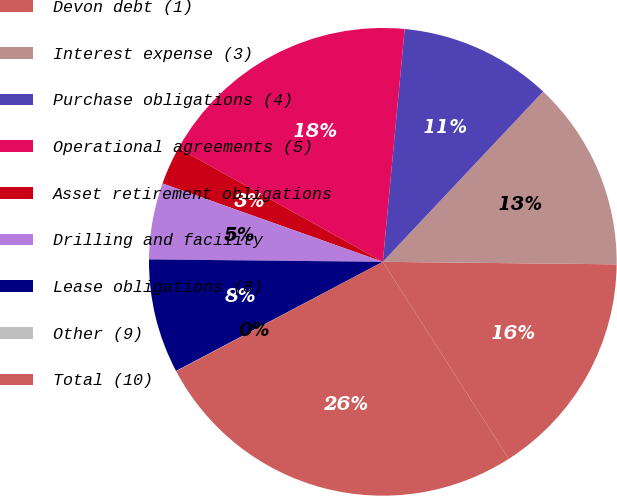<chart> <loc_0><loc_0><loc_500><loc_500><pie_chart><fcel>Devon debt (1)<fcel>Interest expense (3)<fcel>Purchase obligations (4)<fcel>Operational agreements (5)<fcel>Asset retirement obligations<fcel>Drilling and facility<fcel>Lease obligations (8)<fcel>Other (9)<fcel>Total (10)<nl><fcel>15.78%<fcel>13.15%<fcel>10.53%<fcel>18.41%<fcel>2.64%<fcel>5.27%<fcel>7.9%<fcel>0.02%<fcel>26.29%<nl></chart> 